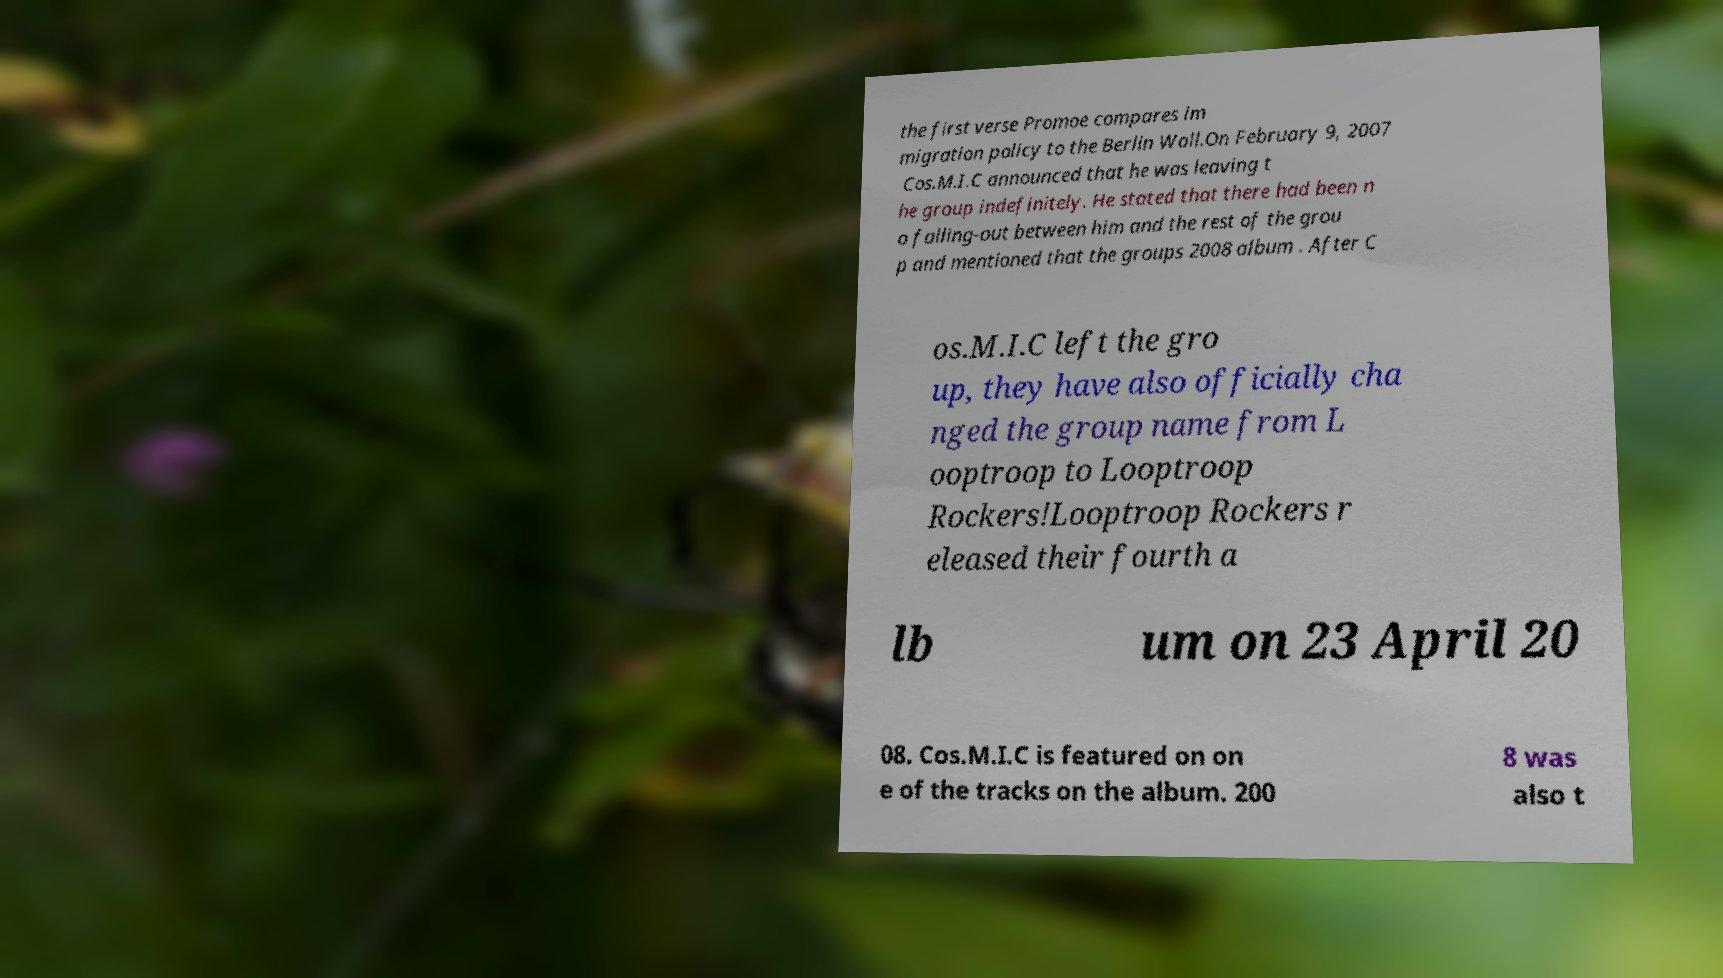I need the written content from this picture converted into text. Can you do that? the first verse Promoe compares im migration policy to the Berlin Wall.On February 9, 2007 Cos.M.I.C announced that he was leaving t he group indefinitely. He stated that there had been n o falling-out between him and the rest of the grou p and mentioned that the groups 2008 album . After C os.M.I.C left the gro up, they have also officially cha nged the group name from L ooptroop to Looptroop Rockers!Looptroop Rockers r eleased their fourth a lb um on 23 April 20 08. Cos.M.I.C is featured on on e of the tracks on the album. 200 8 was also t 